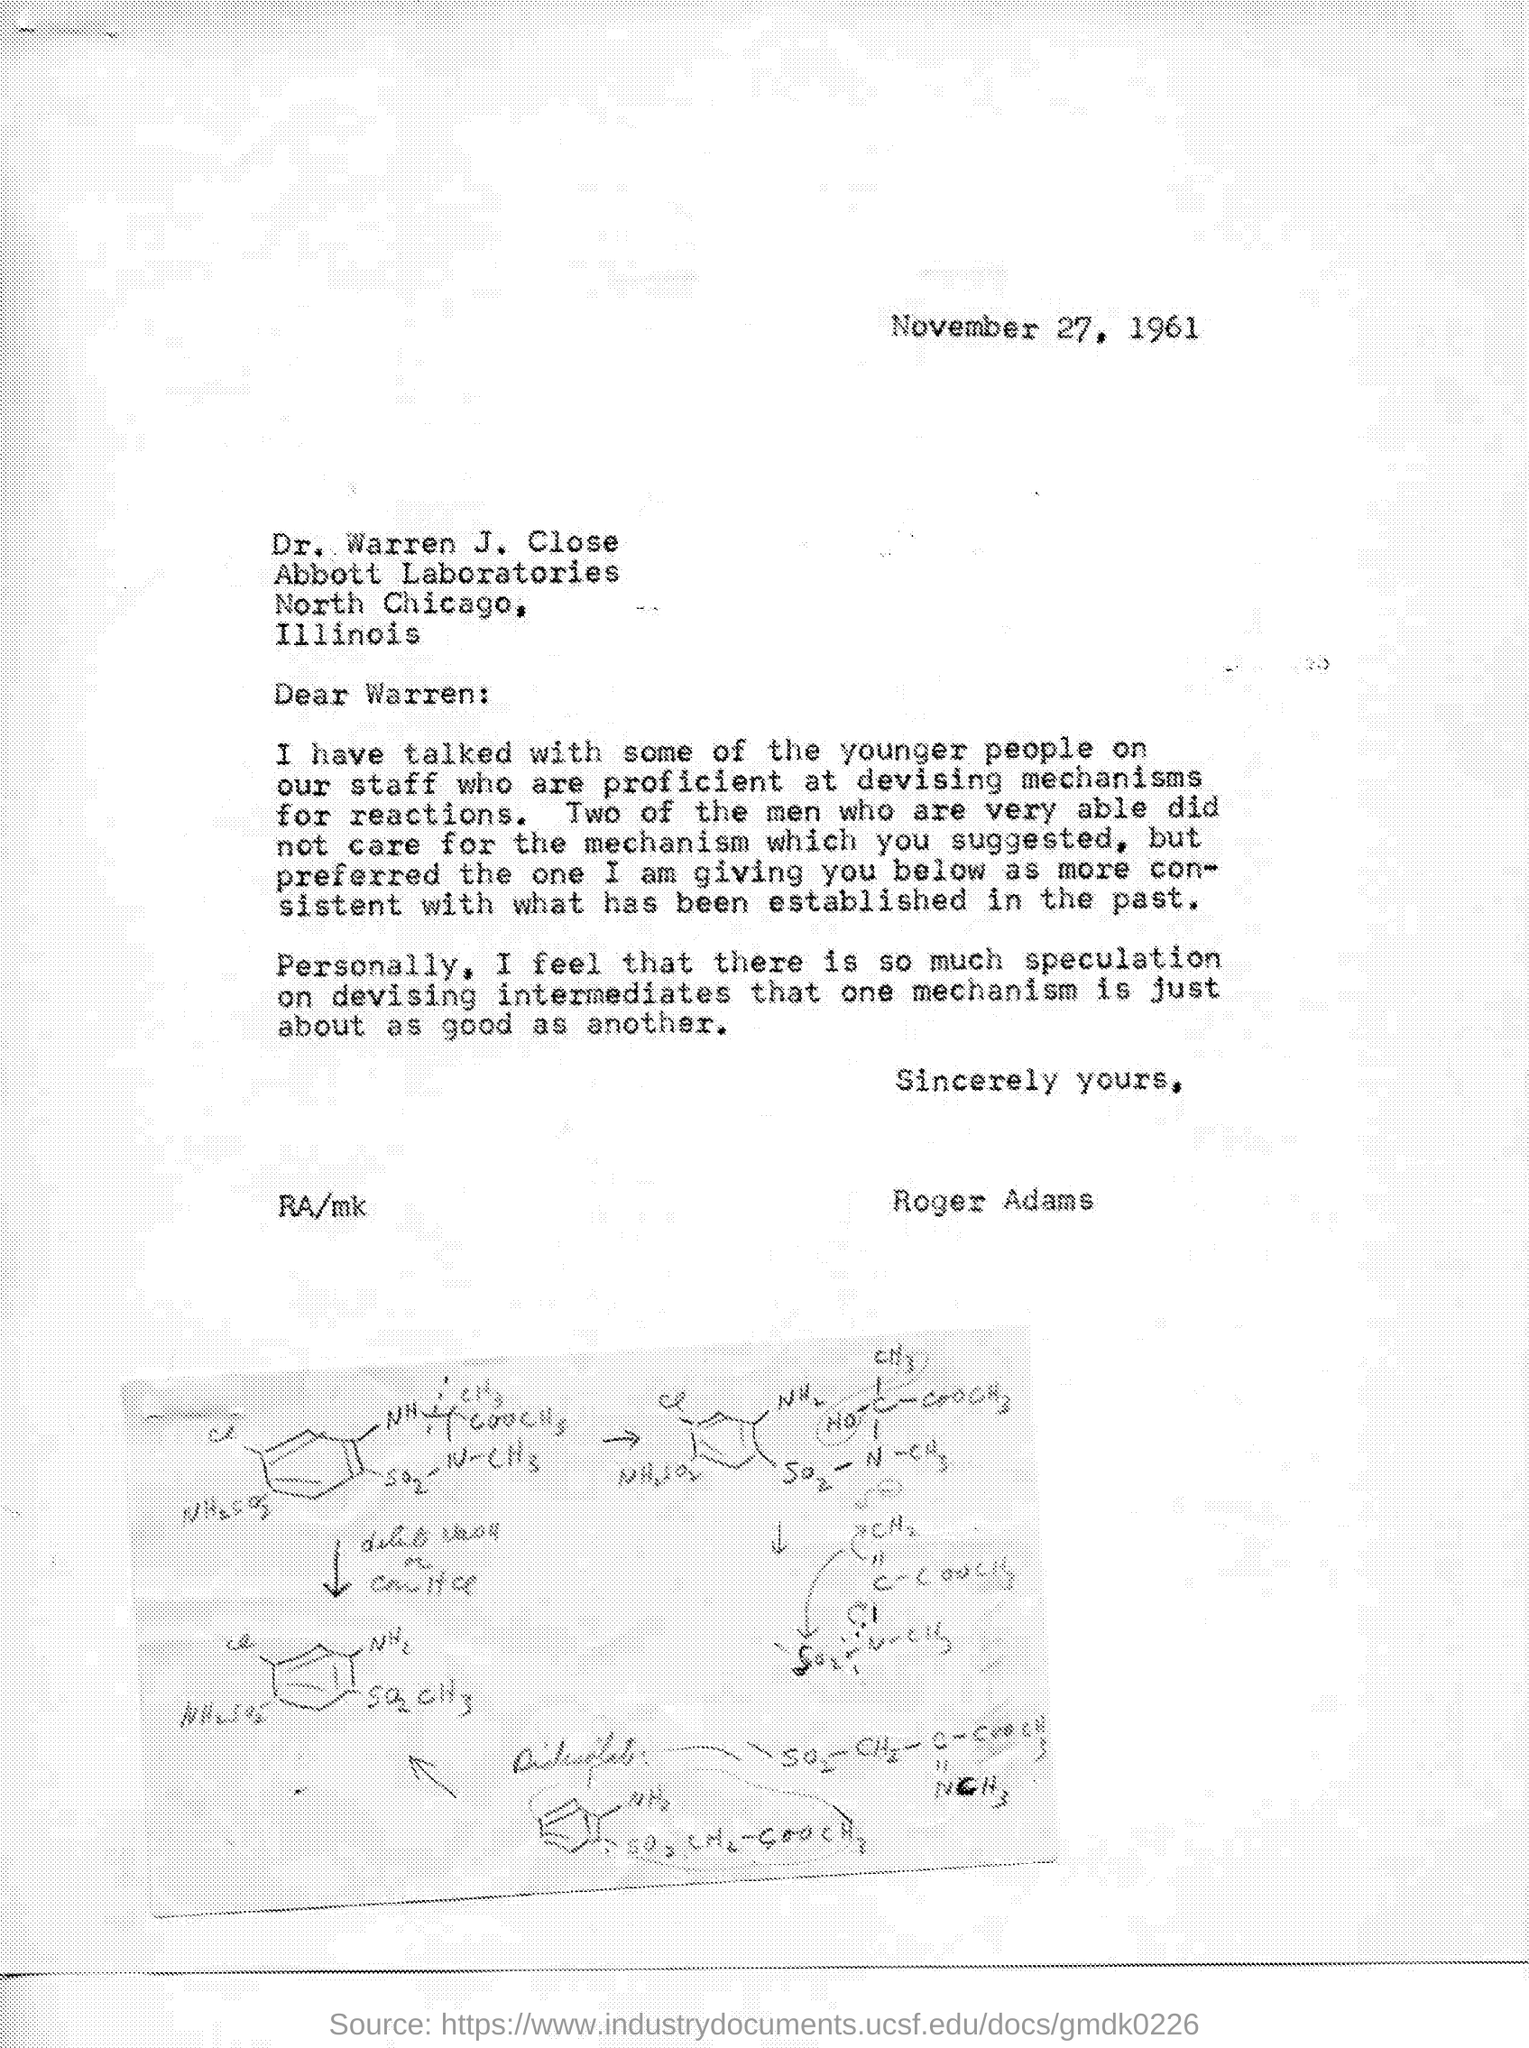Specify some key components in this picture. The letter is addressed to Warren. The letter is dated November 27, 1961. Roger Adams is the sender. 